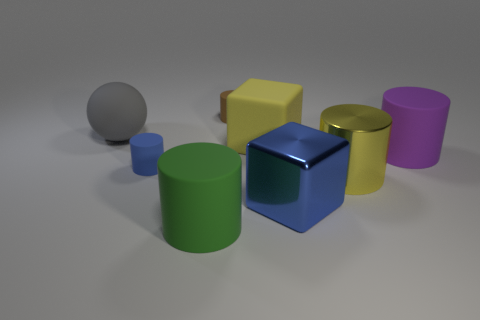The yellow shiny thing that is the same size as the matte ball is what shape?
Make the answer very short. Cylinder. Are there any large metal objects of the same color as the large shiny cube?
Provide a short and direct response. No. The blue matte cylinder is what size?
Provide a short and direct response. Small. Are the large green object and the blue cube made of the same material?
Ensure brevity in your answer.  No. There is a cylinder that is behind the yellow cube to the right of the matte sphere; what number of yellow metal objects are in front of it?
Give a very brief answer. 1. What is the shape of the small thing left of the tiny brown matte cylinder?
Give a very brief answer. Cylinder. What number of other objects are there of the same material as the small brown cylinder?
Keep it short and to the point. 5. Is the color of the large matte ball the same as the metal cylinder?
Your response must be concise. No. Is the number of green cylinders that are right of the purple cylinder less than the number of tiny blue cylinders that are in front of the big yellow metal object?
Give a very brief answer. No. There is another tiny object that is the same shape as the small blue rubber thing; what is its color?
Your answer should be compact. Brown. 